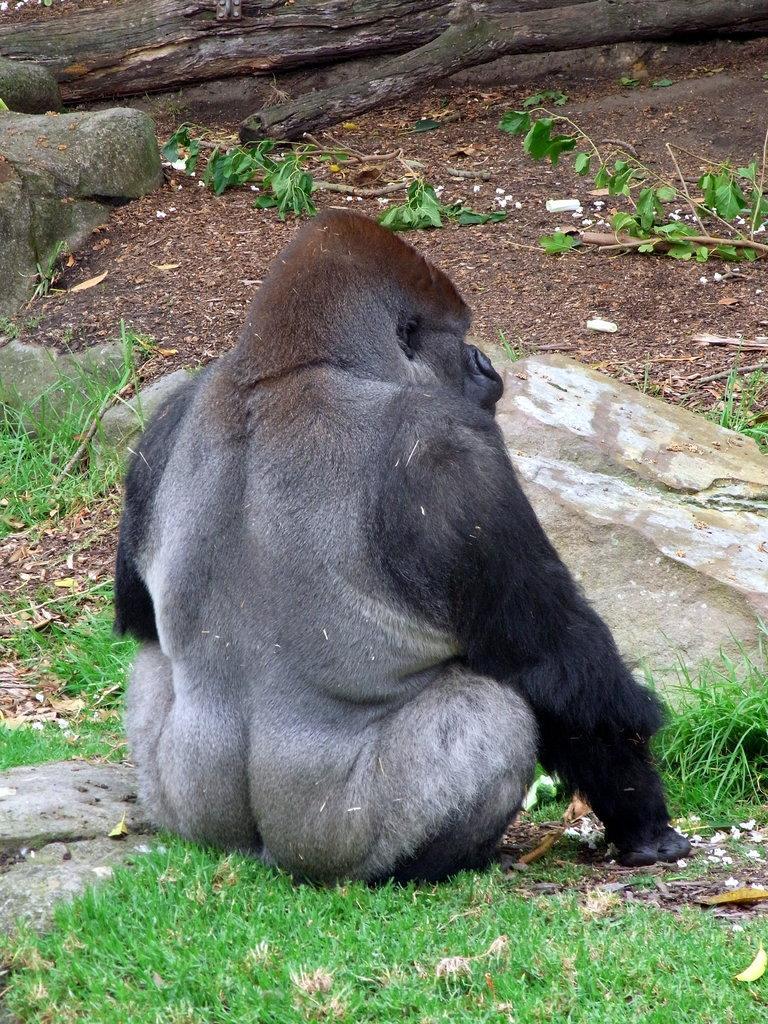Could you give a brief overview of what you see in this image? In this picture there is a chimpanzee sitting. At the back there is a tree trunk and there are tree branches. At the bottom there is grass and there are stones. 